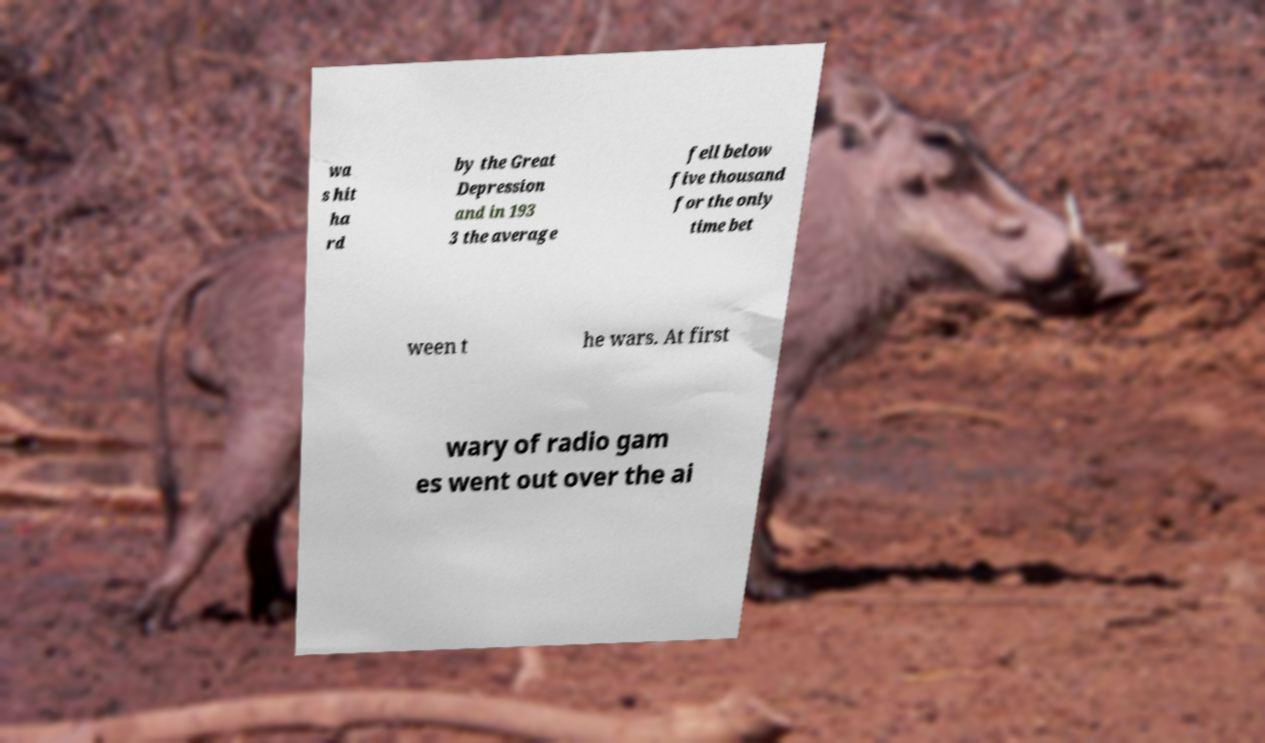Could you assist in decoding the text presented in this image and type it out clearly? wa s hit ha rd by the Great Depression and in 193 3 the average fell below five thousand for the only time bet ween t he wars. At first wary of radio gam es went out over the ai 